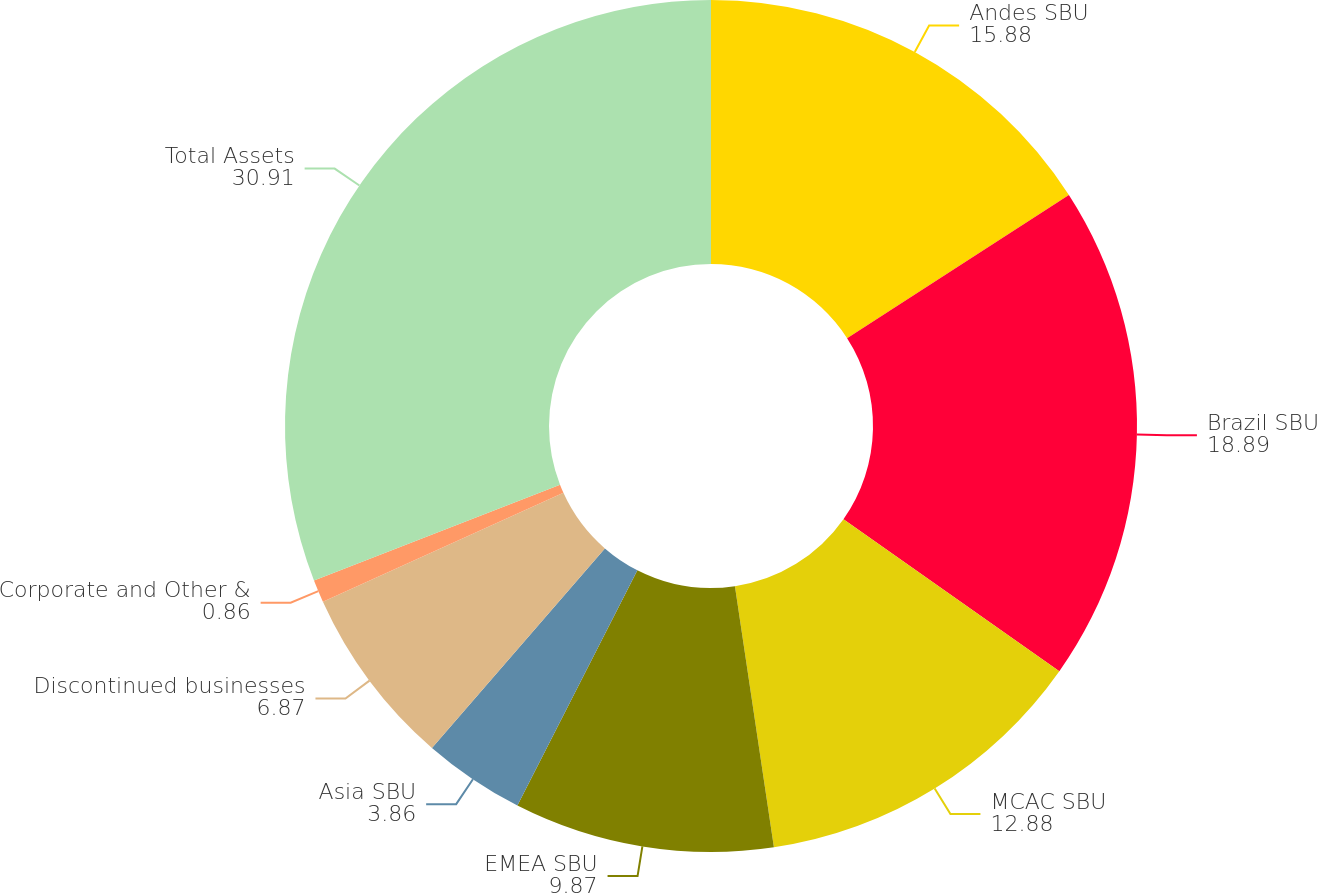Convert chart to OTSL. <chart><loc_0><loc_0><loc_500><loc_500><pie_chart><fcel>Andes SBU<fcel>Brazil SBU<fcel>MCAC SBU<fcel>EMEA SBU<fcel>Asia SBU<fcel>Discontinued businesses<fcel>Corporate and Other &<fcel>Total Assets<nl><fcel>15.88%<fcel>18.89%<fcel>12.88%<fcel>9.87%<fcel>3.86%<fcel>6.87%<fcel>0.86%<fcel>30.91%<nl></chart> 